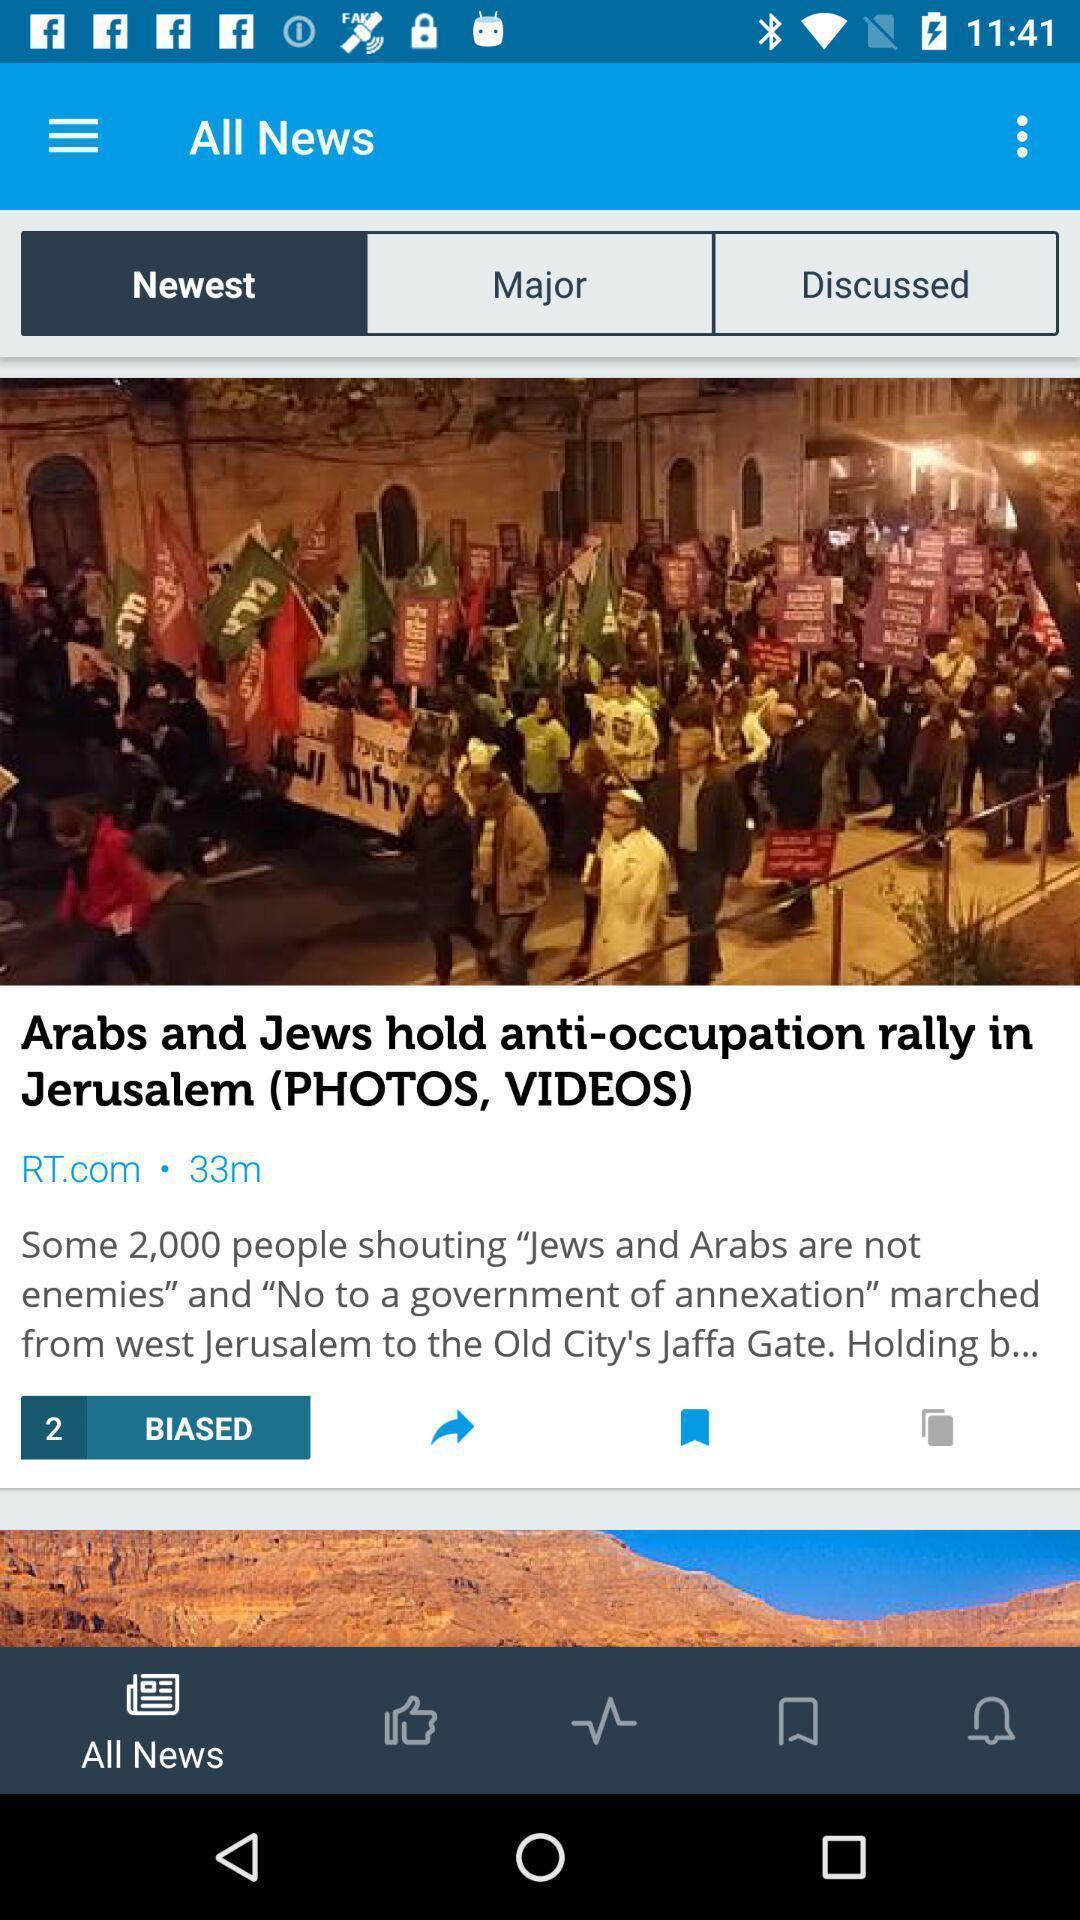Summarize the main components in this picture. Screen showing newest news. 